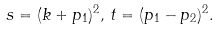<formula> <loc_0><loc_0><loc_500><loc_500>s = ( k + p _ { 1 } ) ^ { 2 } , \, t = ( p _ { 1 } - p _ { 2 } ) ^ { 2 } .</formula> 